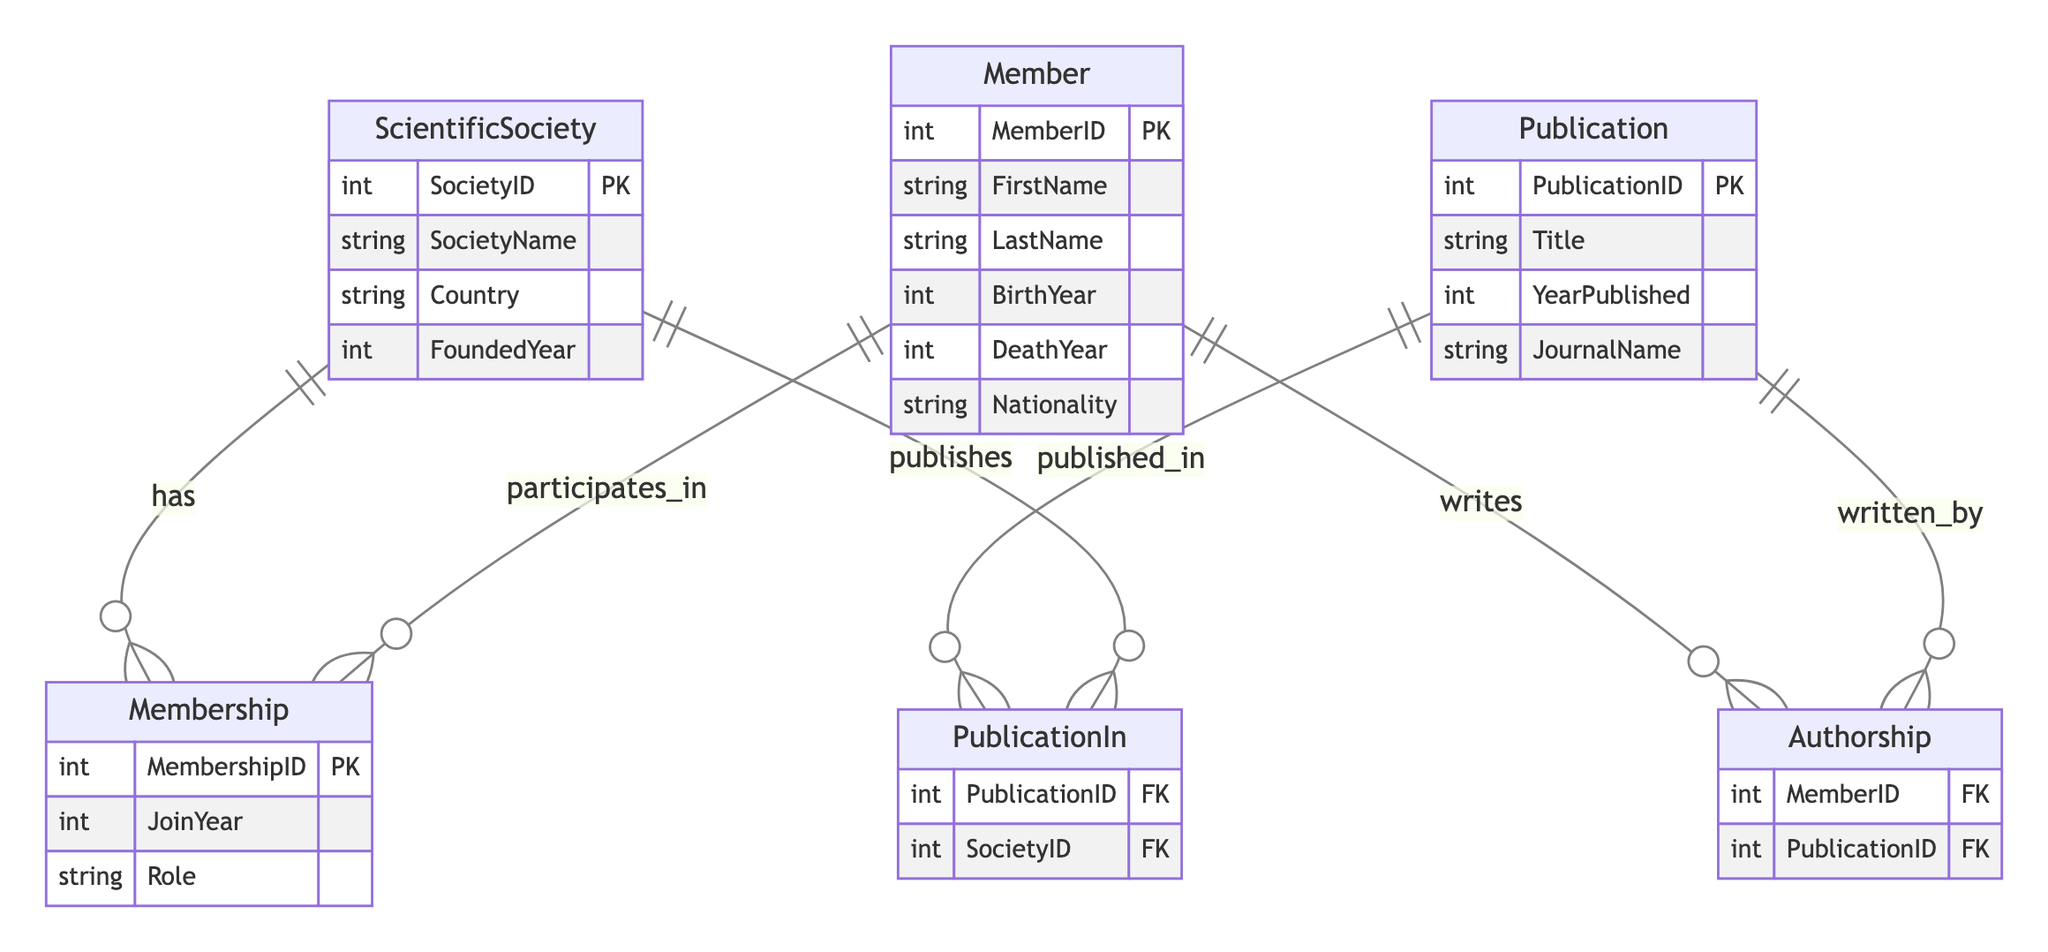What is the primary key of the Member entity? The primary key attribute of the Member entity is identified as MemberID, which uniquely identifies each member within the diagram.
Answer: MemberID How many entities are present in this diagram? The diagram consists of three distinct entities: ScientificSociety, Member, and Publication. Counting these gives us a total of three entities.
Answer: 3 What is the relationship between Member and ScientificSociety? The relationship defined between Member and ScientificSociety is called Membership, indicating that members participate in societies, which is illustrated by the connecting line labeled 'has' and 'participates_in'.
Answer: Membership What additional attribute does the Membership relationship include? The Membership relationship includes additional attributes: MembershipID, JoinYear, and Role, which provide more information about the membership details of each member in a society.
Answer: MembershipID, JoinYear, Role Which entity is linked to the authorship of publications? The Member entity is directly linked to the authorship of publications through the Authorship relationship, which signifies that members are the authors of publications.
Answer: Member How many publications can a member author? A member can author zero or many publications, as indicated by the "o{” on the Authorship relationship, which illustrates a many-to-one relationship. This means that one member can be linked to multiple publication entries.
Answer: Zero or many What type of relationship exists between Publication and ScientificSociety? There is a PublicationIn relationship between Publication and ScientificSociety, indicating that publications are tied to specific scientific societies where they were published.
Answer: PublicationIn Which year is given as an example for a publication attribute? The YearPublished attribute in the Publication entity is an example attribute that references the year a particular publication was issued, illustrating time data related to publications.
Answer: YearPublished What does the role attribute in the Membership relationship denote? The Role attribute in the Membership relationship indicates the specific function or position a member holds within a scientific society, such as president, fellow, etc., reflecting the organizational hierarchy.
Answer: Role 